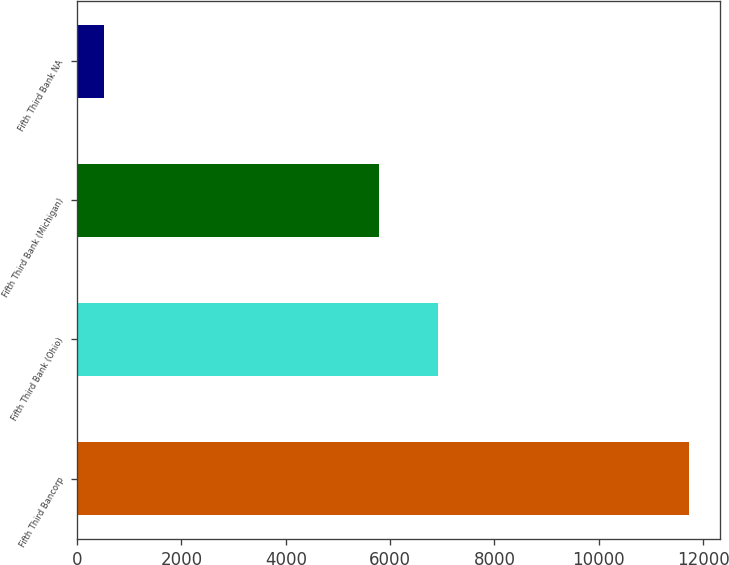Convert chart to OTSL. <chart><loc_0><loc_0><loc_500><loc_500><bar_chart><fcel>Fifth Third Bancorp<fcel>Fifth Third Bank (Ohio)<fcel>Fifth Third Bank (Michigan)<fcel>Fifth Third Bank NA<nl><fcel>11733<fcel>6908.4<fcel>5787<fcel>519<nl></chart> 